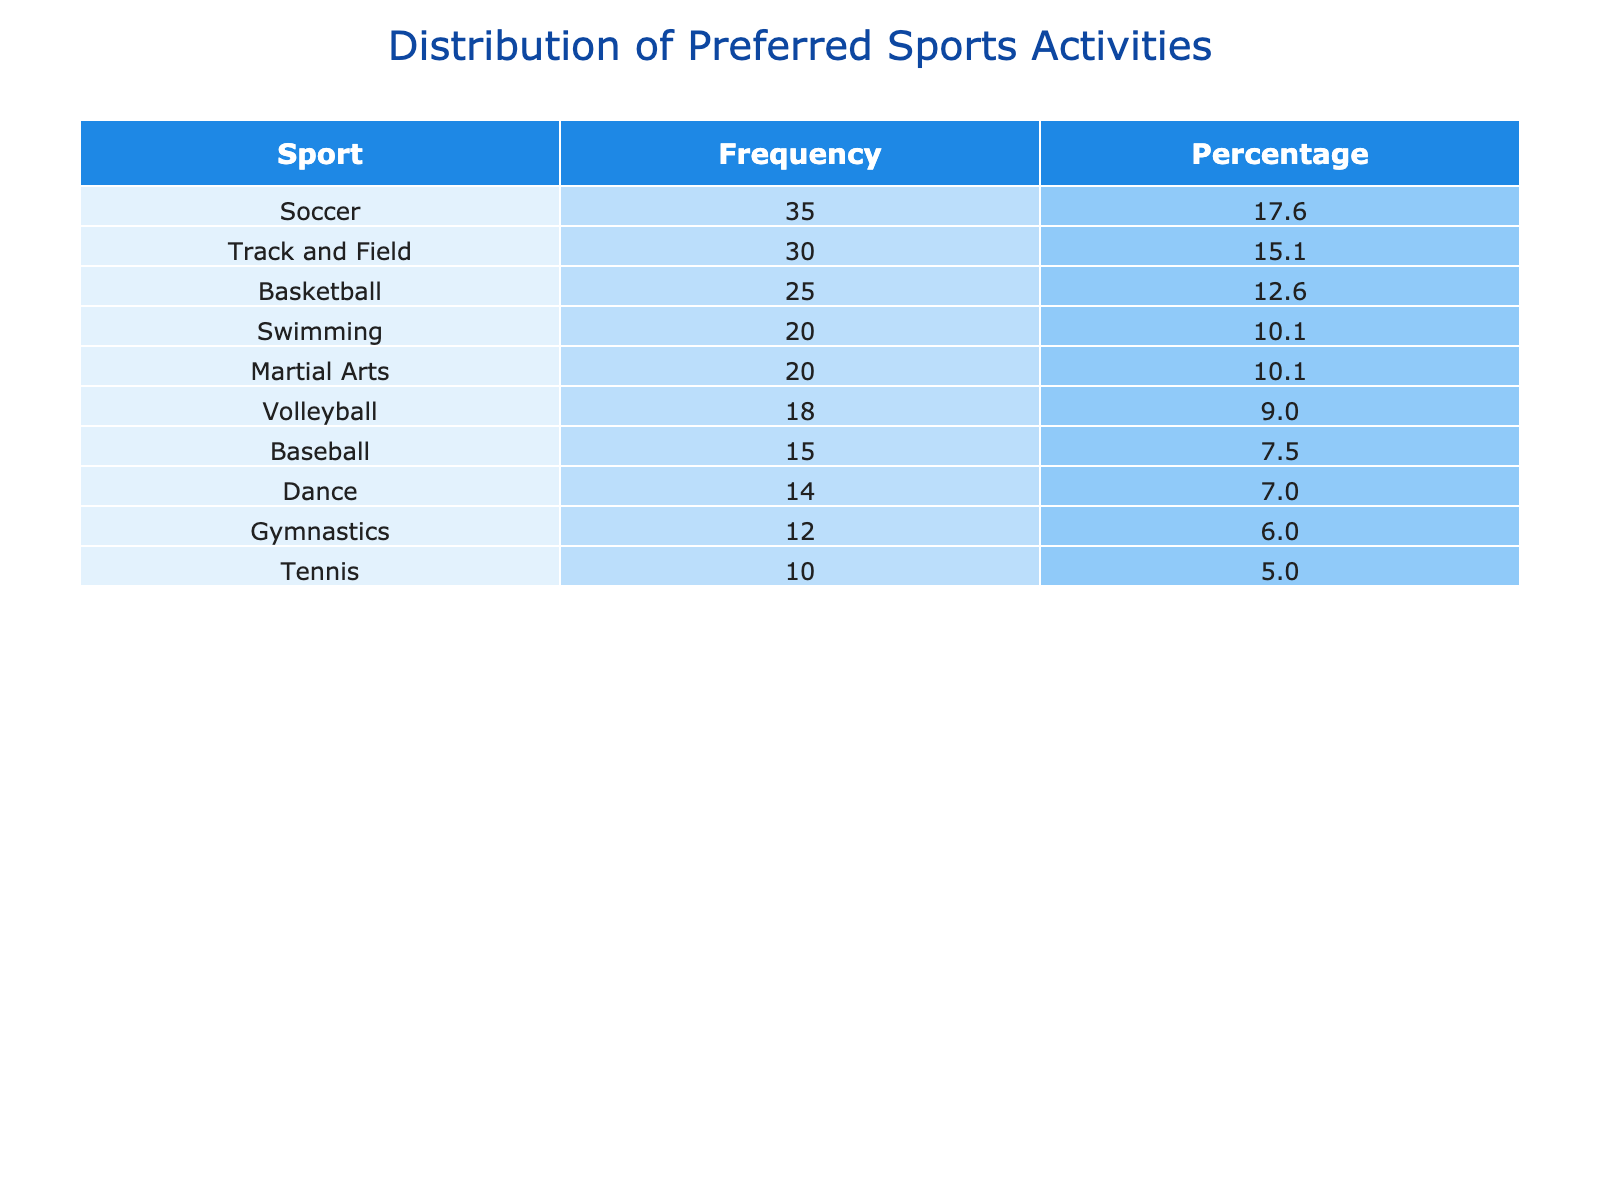What is the frequency of participants who prefer soccer? The table indicates the frequency of participants for each sport. Looking at the row for soccer, the frequency is listed as 35.
Answer: 35 Which sport has the lowest number of participants? By examining the frequency column in the table for each sport, baseball has the lowest number of participants with a frequency of 15.
Answer: Baseball What percentage of participants prefer basketball? To find the percentage of participants who prefer basketball, we check its frequency (25) and divide it by the total number of participants. The total is 35 + 25 + 15 + 20 + 10 + 18 + 12 + 30 + 20 + 14 =  180. The percentage is (25/180) * 100, which equals approximately 13.9%.
Answer: 13.9 What is the total frequency of participants who prefer track and field or gymnastics? First, we find the frequency for track and field (30) and gymnastics (12) from the table. We then add these two frequencies together: 30 + 12 = 42.
Answer: 42 Is there a sport that has exactly 20 participants? We can check the frequency values listed in the table. Both swimming and martial arts have a frequency of 20. Therefore, the answer is yes, two sports have exactly 20 participants.
Answer: Yes Which sport has a higher number of participants, volleyball or dance? We compare the frequencies of volleyball (18) and dance (14). Since 18 is greater than 14, volleyball has more participants than dance.
Answer: Volleyball What is the average number of participants for the sports activities listed? We need to add up all the participant frequencies: 35 + 25 + 15 + 20 + 10 + 18 + 12 + 30 + 20 + 14 =  180 (total). There are 10 sports listed, so to find the average, we divide 180 by 10, resulting in an average of 18.
Answer: 18 How many more participants prefer soccer than tennis? The frequency for soccer is 35 and for tennis, it is 10. To find how many more prefer soccer, we subtract tennis from soccer: 35 - 10 = 25.
Answer: 25 Which sport has a frequency that is less than 15 but more than 10? Looking at the frequencies listed in the table, the only sport that fits this criterion is gymnastics, which has a frequency of 12.
Answer: Gymnastics 